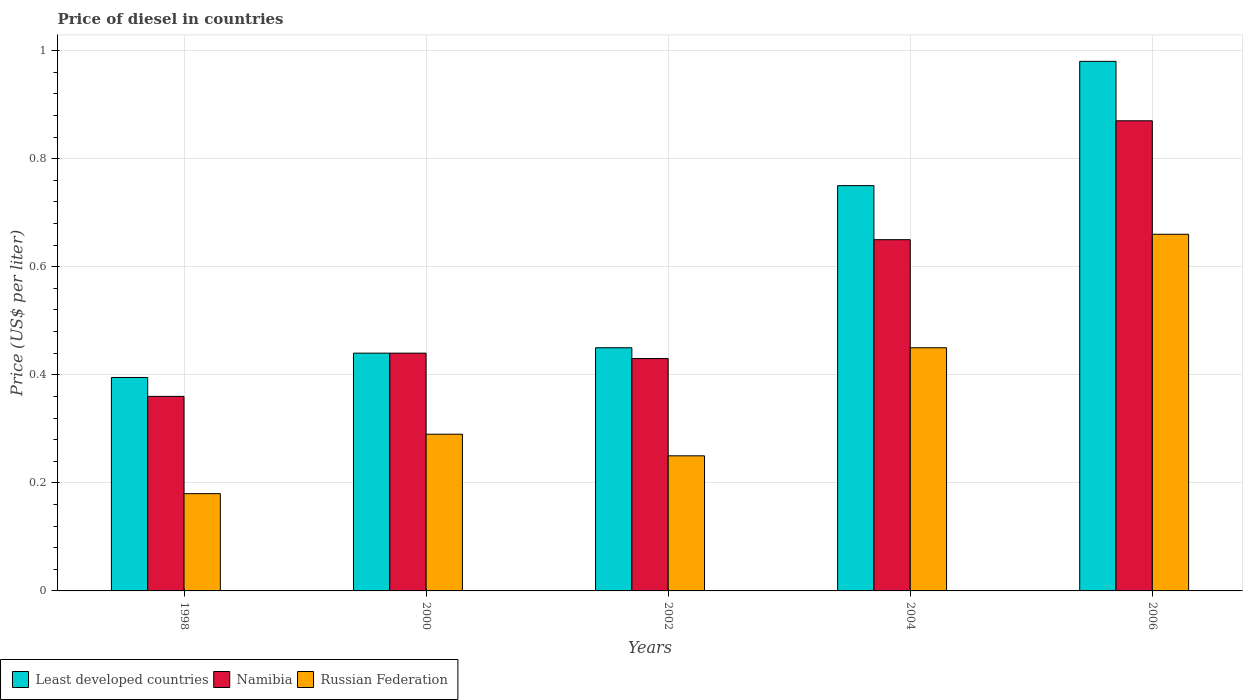In how many cases, is the number of bars for a given year not equal to the number of legend labels?
Your answer should be compact. 0. What is the price of diesel in Russian Federation in 2000?
Offer a terse response. 0.29. Across all years, what is the maximum price of diesel in Namibia?
Keep it short and to the point. 0.87. Across all years, what is the minimum price of diesel in Russian Federation?
Provide a succinct answer. 0.18. In which year was the price of diesel in Russian Federation maximum?
Ensure brevity in your answer.  2006. What is the total price of diesel in Least developed countries in the graph?
Keep it short and to the point. 3.02. What is the difference between the price of diesel in Namibia in 2002 and that in 2006?
Make the answer very short. -0.44. What is the difference between the price of diesel in Namibia in 2000 and the price of diesel in Least developed countries in 2006?
Ensure brevity in your answer.  -0.54. What is the average price of diesel in Russian Federation per year?
Ensure brevity in your answer.  0.37. In the year 2006, what is the difference between the price of diesel in Namibia and price of diesel in Russian Federation?
Offer a very short reply. 0.21. What is the ratio of the price of diesel in Namibia in 2004 to that in 2006?
Give a very brief answer. 0.75. Is the difference between the price of diesel in Namibia in 1998 and 2002 greater than the difference between the price of diesel in Russian Federation in 1998 and 2002?
Make the answer very short. No. What is the difference between the highest and the second highest price of diesel in Least developed countries?
Provide a succinct answer. 0.23. What is the difference between the highest and the lowest price of diesel in Least developed countries?
Your response must be concise. 0.58. What does the 3rd bar from the left in 2006 represents?
Ensure brevity in your answer.  Russian Federation. What does the 1st bar from the right in 2000 represents?
Your answer should be very brief. Russian Federation. How many bars are there?
Offer a very short reply. 15. What is the difference between two consecutive major ticks on the Y-axis?
Provide a succinct answer. 0.2. Are the values on the major ticks of Y-axis written in scientific E-notation?
Your answer should be very brief. No. Does the graph contain any zero values?
Offer a terse response. No. Where does the legend appear in the graph?
Keep it short and to the point. Bottom left. What is the title of the graph?
Your response must be concise. Price of diesel in countries. Does "Tuvalu" appear as one of the legend labels in the graph?
Ensure brevity in your answer.  No. What is the label or title of the Y-axis?
Provide a short and direct response. Price (US$ per liter). What is the Price (US$ per liter) in Least developed countries in 1998?
Provide a short and direct response. 0.4. What is the Price (US$ per liter) of Namibia in 1998?
Your response must be concise. 0.36. What is the Price (US$ per liter) in Russian Federation in 1998?
Provide a succinct answer. 0.18. What is the Price (US$ per liter) in Least developed countries in 2000?
Ensure brevity in your answer.  0.44. What is the Price (US$ per liter) of Namibia in 2000?
Your answer should be compact. 0.44. What is the Price (US$ per liter) of Russian Federation in 2000?
Provide a short and direct response. 0.29. What is the Price (US$ per liter) of Least developed countries in 2002?
Make the answer very short. 0.45. What is the Price (US$ per liter) in Namibia in 2002?
Make the answer very short. 0.43. What is the Price (US$ per liter) of Russian Federation in 2002?
Make the answer very short. 0.25. What is the Price (US$ per liter) in Namibia in 2004?
Your response must be concise. 0.65. What is the Price (US$ per liter) in Russian Federation in 2004?
Give a very brief answer. 0.45. What is the Price (US$ per liter) in Namibia in 2006?
Provide a short and direct response. 0.87. What is the Price (US$ per liter) in Russian Federation in 2006?
Provide a short and direct response. 0.66. Across all years, what is the maximum Price (US$ per liter) in Namibia?
Provide a short and direct response. 0.87. Across all years, what is the maximum Price (US$ per liter) in Russian Federation?
Your response must be concise. 0.66. Across all years, what is the minimum Price (US$ per liter) of Least developed countries?
Provide a short and direct response. 0.4. Across all years, what is the minimum Price (US$ per liter) in Namibia?
Your answer should be very brief. 0.36. Across all years, what is the minimum Price (US$ per liter) of Russian Federation?
Provide a succinct answer. 0.18. What is the total Price (US$ per liter) in Least developed countries in the graph?
Offer a very short reply. 3.02. What is the total Price (US$ per liter) in Namibia in the graph?
Provide a short and direct response. 2.75. What is the total Price (US$ per liter) of Russian Federation in the graph?
Offer a terse response. 1.83. What is the difference between the Price (US$ per liter) of Least developed countries in 1998 and that in 2000?
Your answer should be compact. -0.04. What is the difference between the Price (US$ per liter) in Namibia in 1998 and that in 2000?
Provide a succinct answer. -0.08. What is the difference between the Price (US$ per liter) of Russian Federation in 1998 and that in 2000?
Keep it short and to the point. -0.11. What is the difference between the Price (US$ per liter) in Least developed countries in 1998 and that in 2002?
Provide a succinct answer. -0.06. What is the difference between the Price (US$ per liter) of Namibia in 1998 and that in 2002?
Keep it short and to the point. -0.07. What is the difference between the Price (US$ per liter) of Russian Federation in 1998 and that in 2002?
Provide a short and direct response. -0.07. What is the difference between the Price (US$ per liter) of Least developed countries in 1998 and that in 2004?
Your answer should be very brief. -0.35. What is the difference between the Price (US$ per liter) of Namibia in 1998 and that in 2004?
Your answer should be very brief. -0.29. What is the difference between the Price (US$ per liter) of Russian Federation in 1998 and that in 2004?
Offer a very short reply. -0.27. What is the difference between the Price (US$ per liter) in Least developed countries in 1998 and that in 2006?
Your response must be concise. -0.58. What is the difference between the Price (US$ per liter) of Namibia in 1998 and that in 2006?
Give a very brief answer. -0.51. What is the difference between the Price (US$ per liter) of Russian Federation in 1998 and that in 2006?
Make the answer very short. -0.48. What is the difference between the Price (US$ per liter) of Least developed countries in 2000 and that in 2002?
Ensure brevity in your answer.  -0.01. What is the difference between the Price (US$ per liter) of Least developed countries in 2000 and that in 2004?
Your response must be concise. -0.31. What is the difference between the Price (US$ per liter) of Namibia in 2000 and that in 2004?
Offer a terse response. -0.21. What is the difference between the Price (US$ per liter) of Russian Federation in 2000 and that in 2004?
Offer a very short reply. -0.16. What is the difference between the Price (US$ per liter) in Least developed countries in 2000 and that in 2006?
Your answer should be very brief. -0.54. What is the difference between the Price (US$ per liter) of Namibia in 2000 and that in 2006?
Ensure brevity in your answer.  -0.43. What is the difference between the Price (US$ per liter) of Russian Federation in 2000 and that in 2006?
Provide a succinct answer. -0.37. What is the difference between the Price (US$ per liter) in Namibia in 2002 and that in 2004?
Ensure brevity in your answer.  -0.22. What is the difference between the Price (US$ per liter) in Least developed countries in 2002 and that in 2006?
Offer a very short reply. -0.53. What is the difference between the Price (US$ per liter) of Namibia in 2002 and that in 2006?
Your answer should be very brief. -0.44. What is the difference between the Price (US$ per liter) of Russian Federation in 2002 and that in 2006?
Provide a short and direct response. -0.41. What is the difference between the Price (US$ per liter) in Least developed countries in 2004 and that in 2006?
Give a very brief answer. -0.23. What is the difference between the Price (US$ per liter) in Namibia in 2004 and that in 2006?
Ensure brevity in your answer.  -0.22. What is the difference between the Price (US$ per liter) of Russian Federation in 2004 and that in 2006?
Offer a terse response. -0.21. What is the difference between the Price (US$ per liter) of Least developed countries in 1998 and the Price (US$ per liter) of Namibia in 2000?
Your response must be concise. -0.04. What is the difference between the Price (US$ per liter) in Least developed countries in 1998 and the Price (US$ per liter) in Russian Federation in 2000?
Offer a terse response. 0.1. What is the difference between the Price (US$ per liter) in Namibia in 1998 and the Price (US$ per liter) in Russian Federation in 2000?
Provide a succinct answer. 0.07. What is the difference between the Price (US$ per liter) of Least developed countries in 1998 and the Price (US$ per liter) of Namibia in 2002?
Offer a very short reply. -0.04. What is the difference between the Price (US$ per liter) of Least developed countries in 1998 and the Price (US$ per liter) of Russian Federation in 2002?
Give a very brief answer. 0.14. What is the difference between the Price (US$ per liter) of Namibia in 1998 and the Price (US$ per liter) of Russian Federation in 2002?
Your answer should be compact. 0.11. What is the difference between the Price (US$ per liter) of Least developed countries in 1998 and the Price (US$ per liter) of Namibia in 2004?
Offer a terse response. -0.26. What is the difference between the Price (US$ per liter) of Least developed countries in 1998 and the Price (US$ per liter) of Russian Federation in 2004?
Provide a succinct answer. -0.06. What is the difference between the Price (US$ per liter) of Namibia in 1998 and the Price (US$ per liter) of Russian Federation in 2004?
Give a very brief answer. -0.09. What is the difference between the Price (US$ per liter) of Least developed countries in 1998 and the Price (US$ per liter) of Namibia in 2006?
Offer a terse response. -0.47. What is the difference between the Price (US$ per liter) in Least developed countries in 1998 and the Price (US$ per liter) in Russian Federation in 2006?
Your answer should be very brief. -0.27. What is the difference between the Price (US$ per liter) of Least developed countries in 2000 and the Price (US$ per liter) of Russian Federation in 2002?
Provide a short and direct response. 0.19. What is the difference between the Price (US$ per liter) in Namibia in 2000 and the Price (US$ per liter) in Russian Federation in 2002?
Your response must be concise. 0.19. What is the difference between the Price (US$ per liter) of Least developed countries in 2000 and the Price (US$ per liter) of Namibia in 2004?
Ensure brevity in your answer.  -0.21. What is the difference between the Price (US$ per liter) of Least developed countries in 2000 and the Price (US$ per liter) of Russian Federation in 2004?
Provide a short and direct response. -0.01. What is the difference between the Price (US$ per liter) of Namibia in 2000 and the Price (US$ per liter) of Russian Federation in 2004?
Keep it short and to the point. -0.01. What is the difference between the Price (US$ per liter) of Least developed countries in 2000 and the Price (US$ per liter) of Namibia in 2006?
Provide a short and direct response. -0.43. What is the difference between the Price (US$ per liter) of Least developed countries in 2000 and the Price (US$ per liter) of Russian Federation in 2006?
Offer a terse response. -0.22. What is the difference between the Price (US$ per liter) of Namibia in 2000 and the Price (US$ per liter) of Russian Federation in 2006?
Provide a short and direct response. -0.22. What is the difference between the Price (US$ per liter) of Least developed countries in 2002 and the Price (US$ per liter) of Russian Federation in 2004?
Your answer should be compact. 0. What is the difference between the Price (US$ per liter) in Namibia in 2002 and the Price (US$ per liter) in Russian Federation in 2004?
Keep it short and to the point. -0.02. What is the difference between the Price (US$ per liter) of Least developed countries in 2002 and the Price (US$ per liter) of Namibia in 2006?
Provide a succinct answer. -0.42. What is the difference between the Price (US$ per liter) in Least developed countries in 2002 and the Price (US$ per liter) in Russian Federation in 2006?
Your answer should be very brief. -0.21. What is the difference between the Price (US$ per liter) in Namibia in 2002 and the Price (US$ per liter) in Russian Federation in 2006?
Offer a very short reply. -0.23. What is the difference between the Price (US$ per liter) of Least developed countries in 2004 and the Price (US$ per liter) of Namibia in 2006?
Your answer should be compact. -0.12. What is the difference between the Price (US$ per liter) of Least developed countries in 2004 and the Price (US$ per liter) of Russian Federation in 2006?
Offer a very short reply. 0.09. What is the difference between the Price (US$ per liter) in Namibia in 2004 and the Price (US$ per liter) in Russian Federation in 2006?
Offer a very short reply. -0.01. What is the average Price (US$ per liter) of Least developed countries per year?
Offer a terse response. 0.6. What is the average Price (US$ per liter) of Namibia per year?
Provide a short and direct response. 0.55. What is the average Price (US$ per liter) of Russian Federation per year?
Provide a short and direct response. 0.37. In the year 1998, what is the difference between the Price (US$ per liter) of Least developed countries and Price (US$ per liter) of Namibia?
Provide a short and direct response. 0.04. In the year 1998, what is the difference between the Price (US$ per liter) in Least developed countries and Price (US$ per liter) in Russian Federation?
Provide a short and direct response. 0.21. In the year 1998, what is the difference between the Price (US$ per liter) in Namibia and Price (US$ per liter) in Russian Federation?
Your response must be concise. 0.18. In the year 2000, what is the difference between the Price (US$ per liter) in Least developed countries and Price (US$ per liter) in Namibia?
Ensure brevity in your answer.  0. In the year 2000, what is the difference between the Price (US$ per liter) of Namibia and Price (US$ per liter) of Russian Federation?
Give a very brief answer. 0.15. In the year 2002, what is the difference between the Price (US$ per liter) in Namibia and Price (US$ per liter) in Russian Federation?
Keep it short and to the point. 0.18. In the year 2004, what is the difference between the Price (US$ per liter) of Least developed countries and Price (US$ per liter) of Russian Federation?
Ensure brevity in your answer.  0.3. In the year 2006, what is the difference between the Price (US$ per liter) of Least developed countries and Price (US$ per liter) of Namibia?
Give a very brief answer. 0.11. In the year 2006, what is the difference between the Price (US$ per liter) of Least developed countries and Price (US$ per liter) of Russian Federation?
Provide a succinct answer. 0.32. In the year 2006, what is the difference between the Price (US$ per liter) of Namibia and Price (US$ per liter) of Russian Federation?
Your answer should be very brief. 0.21. What is the ratio of the Price (US$ per liter) of Least developed countries in 1998 to that in 2000?
Provide a succinct answer. 0.9. What is the ratio of the Price (US$ per liter) of Namibia in 1998 to that in 2000?
Keep it short and to the point. 0.82. What is the ratio of the Price (US$ per liter) of Russian Federation in 1998 to that in 2000?
Give a very brief answer. 0.62. What is the ratio of the Price (US$ per liter) of Least developed countries in 1998 to that in 2002?
Make the answer very short. 0.88. What is the ratio of the Price (US$ per liter) in Namibia in 1998 to that in 2002?
Your response must be concise. 0.84. What is the ratio of the Price (US$ per liter) of Russian Federation in 1998 to that in 2002?
Ensure brevity in your answer.  0.72. What is the ratio of the Price (US$ per liter) in Least developed countries in 1998 to that in 2004?
Your response must be concise. 0.53. What is the ratio of the Price (US$ per liter) in Namibia in 1998 to that in 2004?
Provide a succinct answer. 0.55. What is the ratio of the Price (US$ per liter) in Russian Federation in 1998 to that in 2004?
Provide a short and direct response. 0.4. What is the ratio of the Price (US$ per liter) in Least developed countries in 1998 to that in 2006?
Make the answer very short. 0.4. What is the ratio of the Price (US$ per liter) in Namibia in 1998 to that in 2006?
Provide a short and direct response. 0.41. What is the ratio of the Price (US$ per liter) of Russian Federation in 1998 to that in 2006?
Offer a terse response. 0.27. What is the ratio of the Price (US$ per liter) in Least developed countries in 2000 to that in 2002?
Keep it short and to the point. 0.98. What is the ratio of the Price (US$ per liter) in Namibia in 2000 to that in 2002?
Keep it short and to the point. 1.02. What is the ratio of the Price (US$ per liter) of Russian Federation in 2000 to that in 2002?
Your answer should be very brief. 1.16. What is the ratio of the Price (US$ per liter) of Least developed countries in 2000 to that in 2004?
Your answer should be compact. 0.59. What is the ratio of the Price (US$ per liter) of Namibia in 2000 to that in 2004?
Offer a terse response. 0.68. What is the ratio of the Price (US$ per liter) of Russian Federation in 2000 to that in 2004?
Offer a terse response. 0.64. What is the ratio of the Price (US$ per liter) in Least developed countries in 2000 to that in 2006?
Provide a short and direct response. 0.45. What is the ratio of the Price (US$ per liter) in Namibia in 2000 to that in 2006?
Provide a short and direct response. 0.51. What is the ratio of the Price (US$ per liter) in Russian Federation in 2000 to that in 2006?
Give a very brief answer. 0.44. What is the ratio of the Price (US$ per liter) of Least developed countries in 2002 to that in 2004?
Your answer should be compact. 0.6. What is the ratio of the Price (US$ per liter) of Namibia in 2002 to that in 2004?
Your answer should be compact. 0.66. What is the ratio of the Price (US$ per liter) of Russian Federation in 2002 to that in 2004?
Make the answer very short. 0.56. What is the ratio of the Price (US$ per liter) of Least developed countries in 2002 to that in 2006?
Keep it short and to the point. 0.46. What is the ratio of the Price (US$ per liter) in Namibia in 2002 to that in 2006?
Provide a succinct answer. 0.49. What is the ratio of the Price (US$ per liter) in Russian Federation in 2002 to that in 2006?
Your answer should be compact. 0.38. What is the ratio of the Price (US$ per liter) of Least developed countries in 2004 to that in 2006?
Your response must be concise. 0.77. What is the ratio of the Price (US$ per liter) of Namibia in 2004 to that in 2006?
Give a very brief answer. 0.75. What is the ratio of the Price (US$ per liter) of Russian Federation in 2004 to that in 2006?
Provide a succinct answer. 0.68. What is the difference between the highest and the second highest Price (US$ per liter) in Least developed countries?
Provide a succinct answer. 0.23. What is the difference between the highest and the second highest Price (US$ per liter) in Namibia?
Make the answer very short. 0.22. What is the difference between the highest and the second highest Price (US$ per liter) in Russian Federation?
Offer a terse response. 0.21. What is the difference between the highest and the lowest Price (US$ per liter) in Least developed countries?
Give a very brief answer. 0.58. What is the difference between the highest and the lowest Price (US$ per liter) of Namibia?
Make the answer very short. 0.51. What is the difference between the highest and the lowest Price (US$ per liter) of Russian Federation?
Make the answer very short. 0.48. 